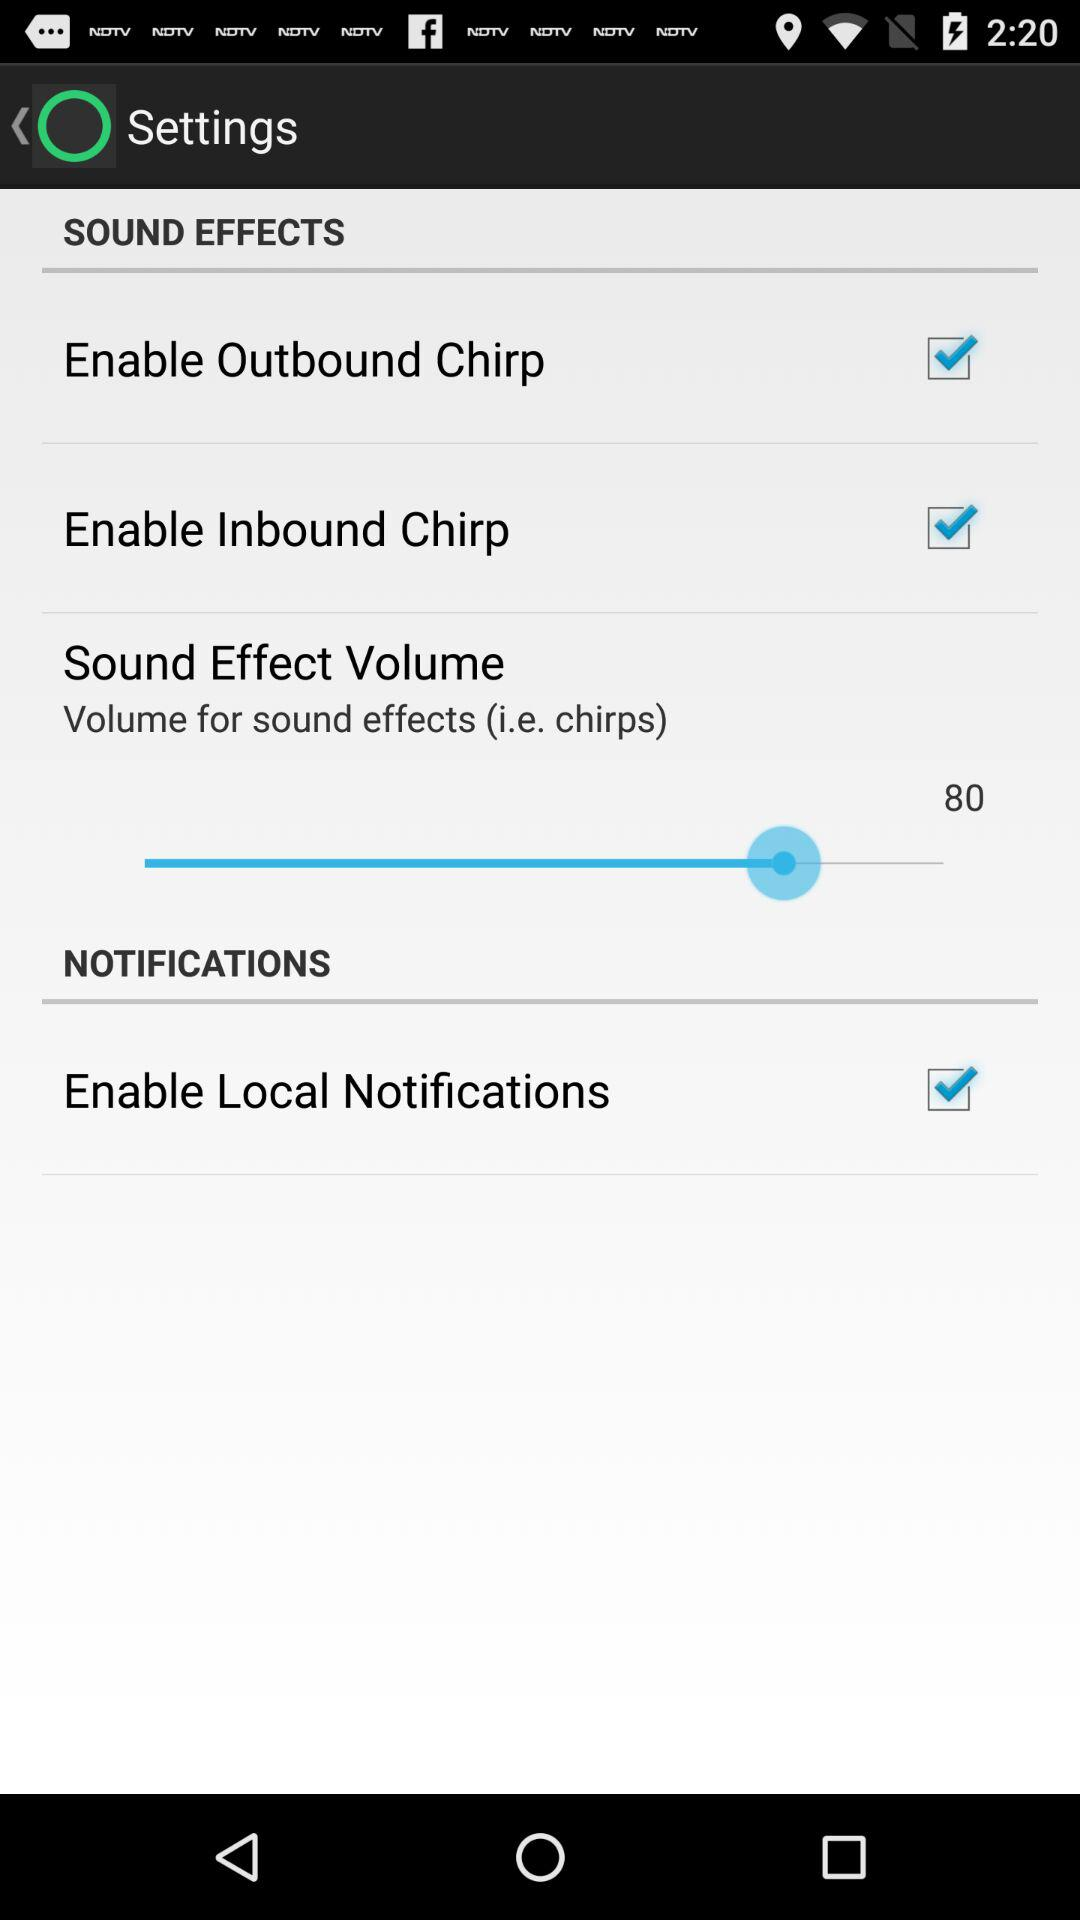What is the status of "Enable Outbound Chirp"? The status is "on". 